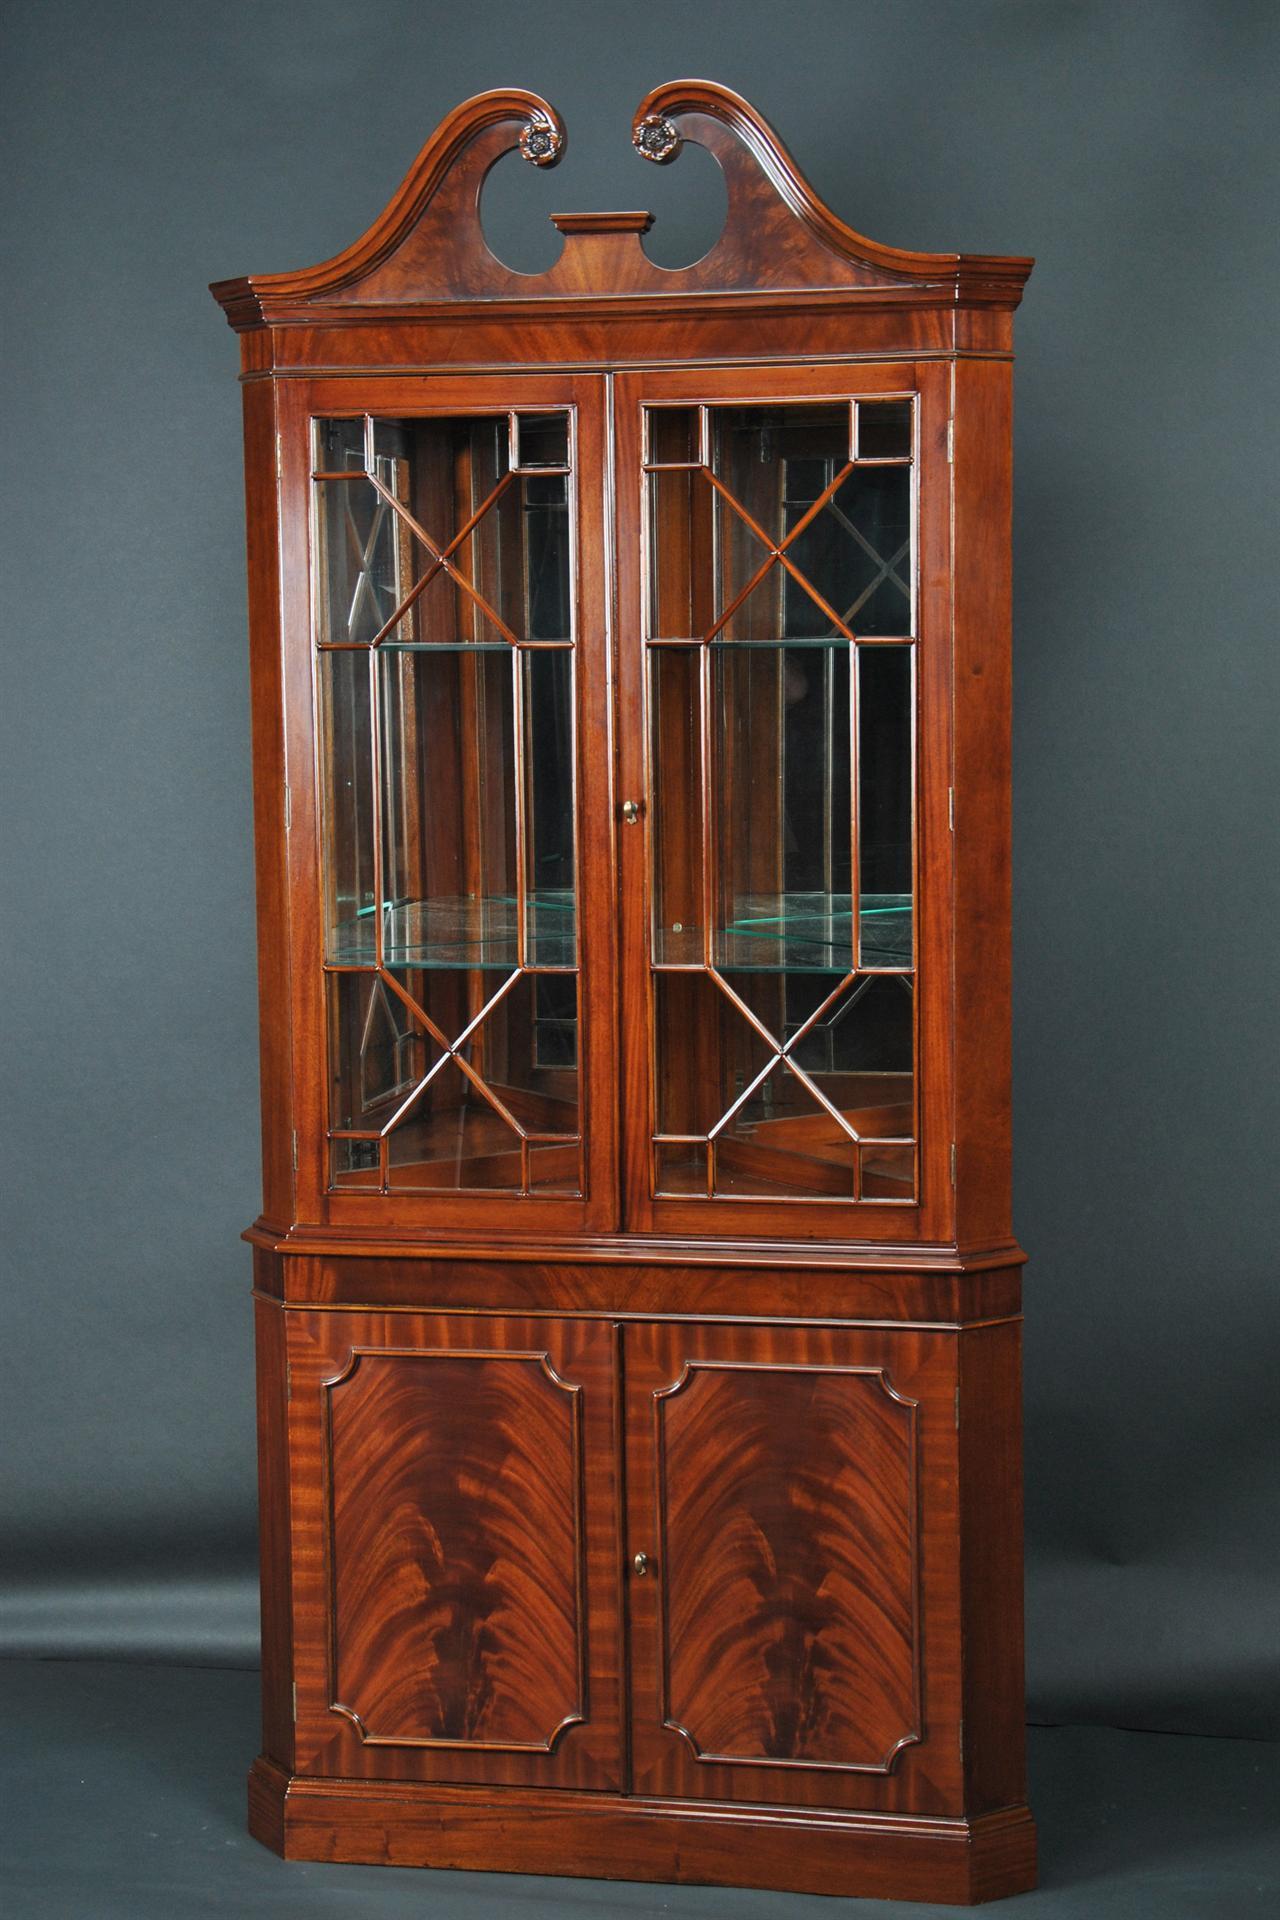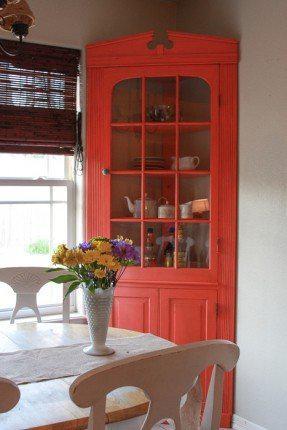The first image is the image on the left, the second image is the image on the right. Analyze the images presented: Is the assertion "At least two round plates are clearly visible in the image on the right." valid? Answer yes or no. No. 